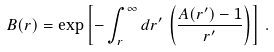Convert formula to latex. <formula><loc_0><loc_0><loc_500><loc_500>B ( r ) = \exp \left [ - \int _ { r } ^ { \infty } d r ^ { \prime } \, \left ( \frac { A ( r ^ { \prime } ) - 1 } { r ^ { \prime } } \right ) \right ] \, .</formula> 